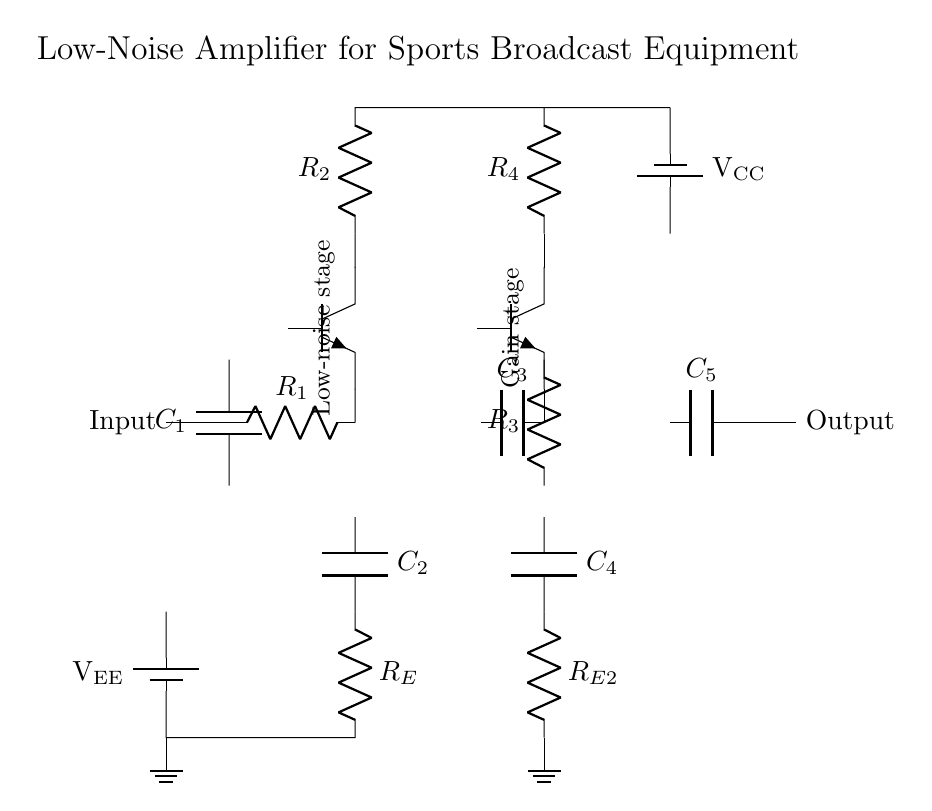What is the input component of the circuit? The input component is a capacitor labeled C1, which is connected to the input of the circuit.
Answer: C1 What is the purpose of R_E in this circuit? R_E is utilized as an emitter resistor in the first stage to provide stability and biasing for the transistor Q1, improving linearity and reducing distortion.
Answer: Stabilization What type of transistors are used in this circuit? The circuit uses NPN transistors, identified as Q1 and Q2, which are commonly used in amplifier designs.
Answer: NPN What is the output component of this low-noise amplifier? The output component is a capacitor labeled C5, which smooths and filters the amplified signal before output.
Answer: C5 Which component is responsible for coupling in the first stage? The coupling in the first stage is primarily handled by the capacitor C1, allowing AC signals to pass while blocking DC, thus preventing DC offset issues at the input.
Answer: C1 How many stages are present in the amplifier circuit? The circuit operates with two amplifier stages, enabling multiple levels of gain through the interaction of Q1 and Q2.
Answer: Two 